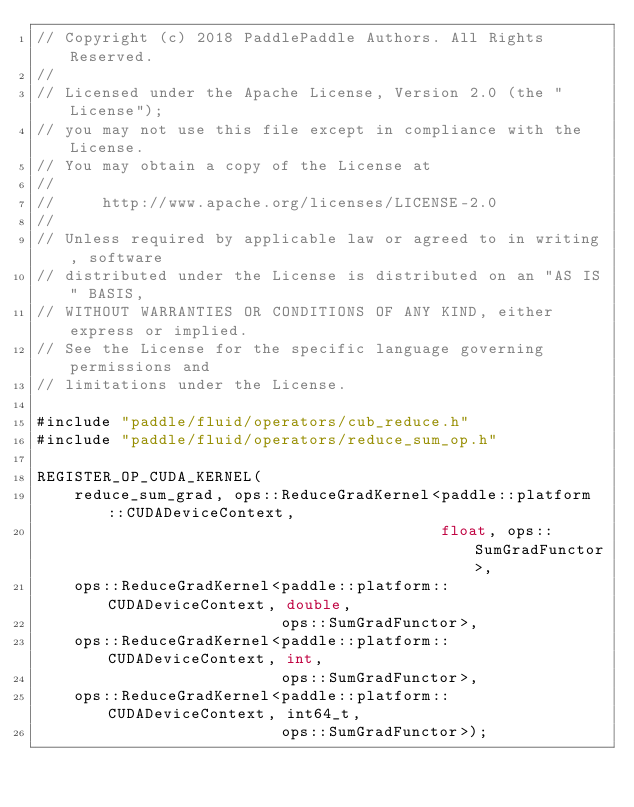Convert code to text. <code><loc_0><loc_0><loc_500><loc_500><_Cuda_>// Copyright (c) 2018 PaddlePaddle Authors. All Rights Reserved.
//
// Licensed under the Apache License, Version 2.0 (the "License");
// you may not use this file except in compliance with the License.
// You may obtain a copy of the License at
//
//     http://www.apache.org/licenses/LICENSE-2.0
//
// Unless required by applicable law or agreed to in writing, software
// distributed under the License is distributed on an "AS IS" BASIS,
// WITHOUT WARRANTIES OR CONDITIONS OF ANY KIND, either express or implied.
// See the License for the specific language governing permissions and
// limitations under the License.

#include "paddle/fluid/operators/cub_reduce.h"
#include "paddle/fluid/operators/reduce_sum_op.h"

REGISTER_OP_CUDA_KERNEL(
    reduce_sum_grad, ops::ReduceGradKernel<paddle::platform::CUDADeviceContext,
                                           float, ops::SumGradFunctor>,
    ops::ReduceGradKernel<paddle::platform::CUDADeviceContext, double,
                          ops::SumGradFunctor>,
    ops::ReduceGradKernel<paddle::platform::CUDADeviceContext, int,
                          ops::SumGradFunctor>,
    ops::ReduceGradKernel<paddle::platform::CUDADeviceContext, int64_t,
                          ops::SumGradFunctor>);
</code> 